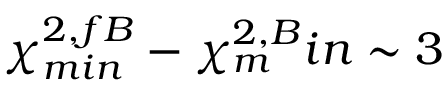<formula> <loc_0><loc_0><loc_500><loc_500>\chi _ { \min } ^ { 2 , f B } - \chi _ { m } ^ { 2 , B } i n \sim 3</formula> 